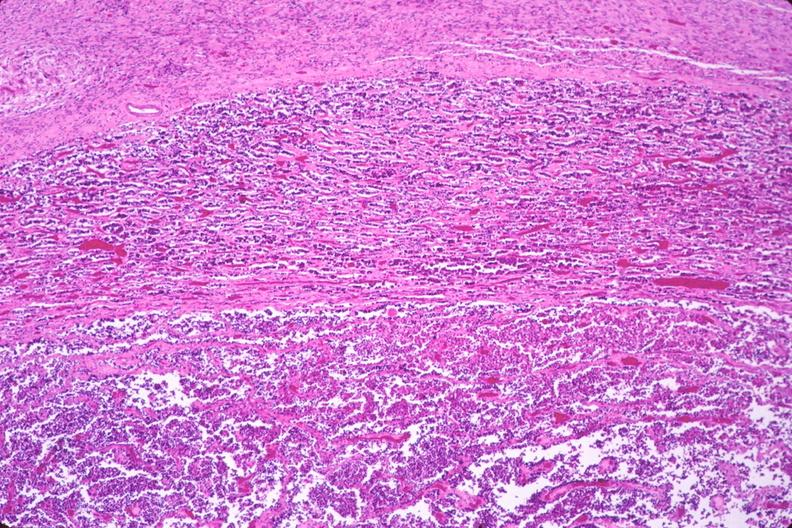where is this part in the figure?
Answer the question using a single word or phrase. Endocrine system 